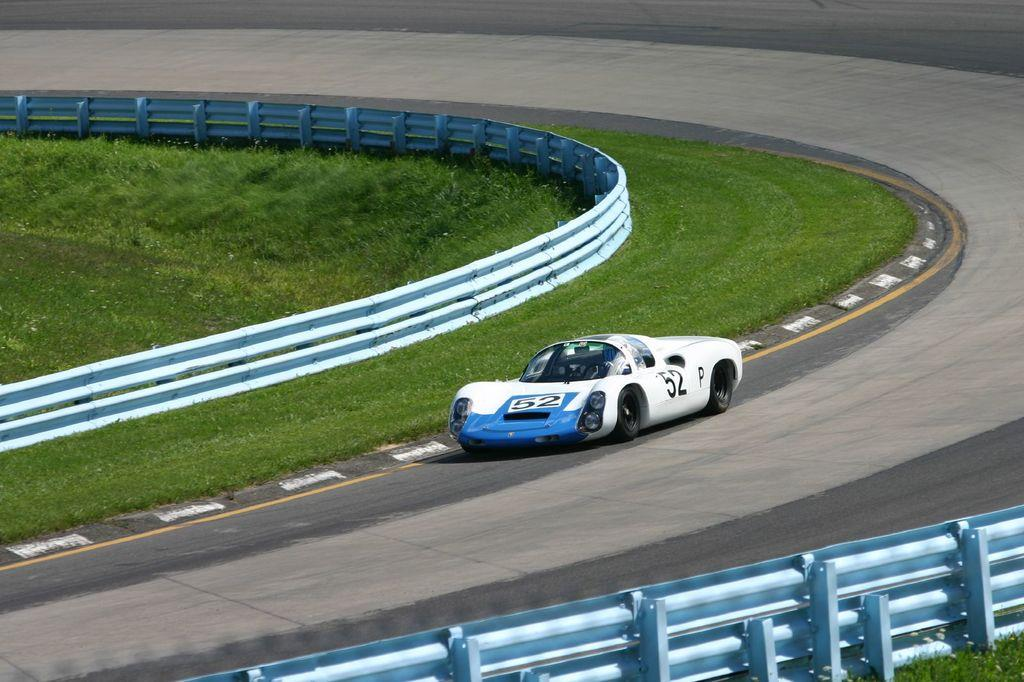What is the main subject of the image? There is a car in the image. Where is the car located? The car is on the road. What is at the bottom of the image? There is fencing at the bottom of the image. What type of vegetation can be seen in the image? There is grass visible in the image. What grade is the toy car in the image? There is no toy car present in the image, and therefore, no grade can be assigned. 